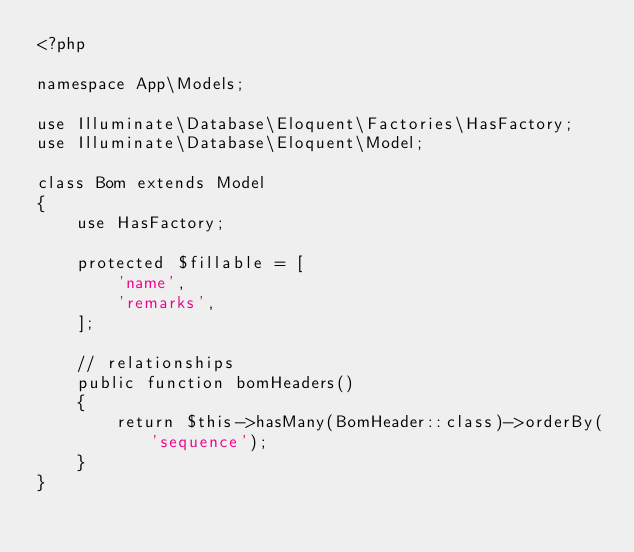Convert code to text. <code><loc_0><loc_0><loc_500><loc_500><_PHP_><?php

namespace App\Models;

use Illuminate\Database\Eloquent\Factories\HasFactory;
use Illuminate\Database\Eloquent\Model;

class Bom extends Model
{
    use HasFactory;

    protected $fillable = [
        'name',
        'remarks',
    ];

    // relationships
    public function bomHeaders()
    {
        return $this->hasMany(BomHeader::class)->orderBy('sequence');
    }
}
</code> 